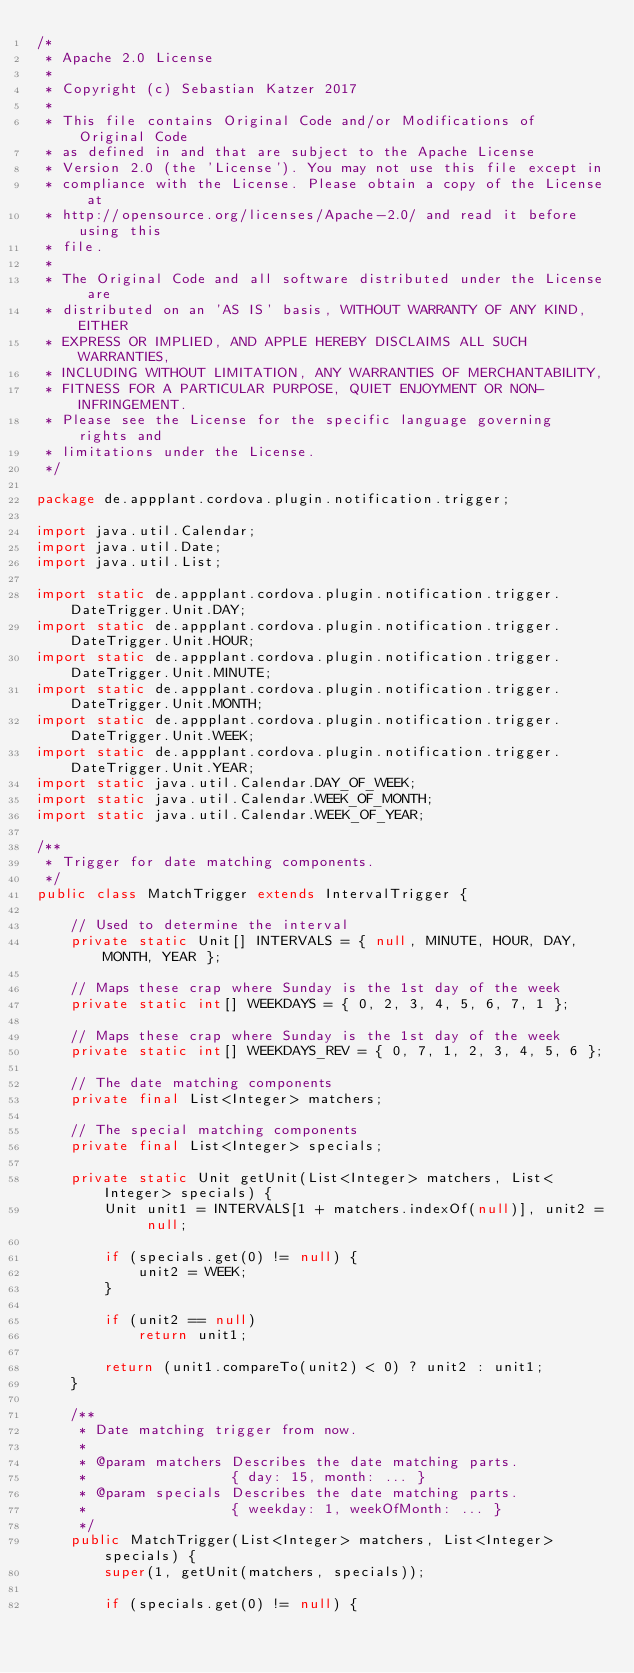Convert code to text. <code><loc_0><loc_0><loc_500><loc_500><_Java_>/*
 * Apache 2.0 License
 *
 * Copyright (c) Sebastian Katzer 2017
 *
 * This file contains Original Code and/or Modifications of Original Code
 * as defined in and that are subject to the Apache License
 * Version 2.0 (the 'License'). You may not use this file except in
 * compliance with the License. Please obtain a copy of the License at
 * http://opensource.org/licenses/Apache-2.0/ and read it before using this
 * file.
 *
 * The Original Code and all software distributed under the License are
 * distributed on an 'AS IS' basis, WITHOUT WARRANTY OF ANY KIND, EITHER
 * EXPRESS OR IMPLIED, AND APPLE HEREBY DISCLAIMS ALL SUCH WARRANTIES,
 * INCLUDING WITHOUT LIMITATION, ANY WARRANTIES OF MERCHANTABILITY,
 * FITNESS FOR A PARTICULAR PURPOSE, QUIET ENJOYMENT OR NON-INFRINGEMENT.
 * Please see the License for the specific language governing rights and
 * limitations under the License.
 */

package de.appplant.cordova.plugin.notification.trigger;

import java.util.Calendar;
import java.util.Date;
import java.util.List;

import static de.appplant.cordova.plugin.notification.trigger.DateTrigger.Unit.DAY;
import static de.appplant.cordova.plugin.notification.trigger.DateTrigger.Unit.HOUR;
import static de.appplant.cordova.plugin.notification.trigger.DateTrigger.Unit.MINUTE;
import static de.appplant.cordova.plugin.notification.trigger.DateTrigger.Unit.MONTH;
import static de.appplant.cordova.plugin.notification.trigger.DateTrigger.Unit.WEEK;
import static de.appplant.cordova.plugin.notification.trigger.DateTrigger.Unit.YEAR;
import static java.util.Calendar.DAY_OF_WEEK;
import static java.util.Calendar.WEEK_OF_MONTH;
import static java.util.Calendar.WEEK_OF_YEAR;

/**
 * Trigger for date matching components.
 */
public class MatchTrigger extends IntervalTrigger {

    // Used to determine the interval
    private static Unit[] INTERVALS = { null, MINUTE, HOUR, DAY, MONTH, YEAR };

    // Maps these crap where Sunday is the 1st day of the week
    private static int[] WEEKDAYS = { 0, 2, 3, 4, 5, 6, 7, 1 };

    // Maps these crap where Sunday is the 1st day of the week
    private static int[] WEEKDAYS_REV = { 0, 7, 1, 2, 3, 4, 5, 6 };

    // The date matching components
    private final List<Integer> matchers;

    // The special matching components
    private final List<Integer> specials;

    private static Unit getUnit(List<Integer> matchers, List<Integer> specials) {
        Unit unit1 = INTERVALS[1 + matchers.indexOf(null)], unit2 = null;

        if (specials.get(0) != null) {
            unit2 = WEEK;
        }

        if (unit2 == null)
            return unit1;

        return (unit1.compareTo(unit2) < 0) ? unit2 : unit1;
    }

    /**
     * Date matching trigger from now.
     *
     * @param matchers Describes the date matching parts.
     *                 { day: 15, month: ... }
     * @param specials Describes the date matching parts.
     *                 { weekday: 1, weekOfMonth: ... }
     */
    public MatchTrigger(List<Integer> matchers, List<Integer> specials) {
        super(1, getUnit(matchers, specials));

        if (specials.get(0) != null) {</code> 